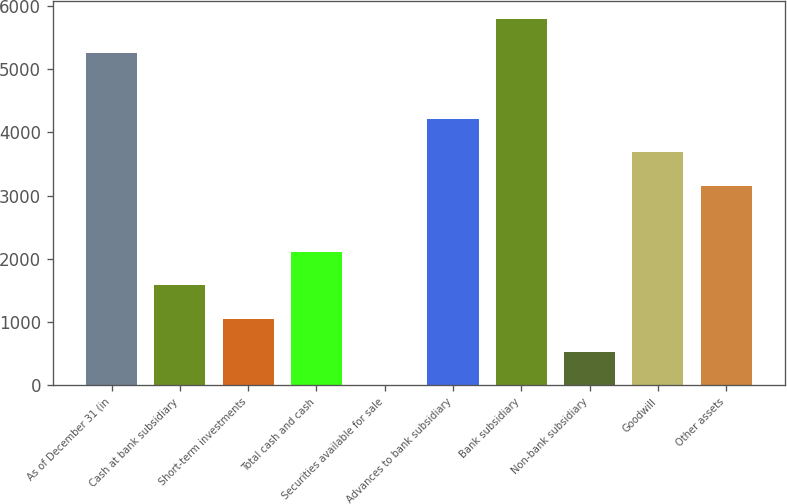Convert chart. <chart><loc_0><loc_0><loc_500><loc_500><bar_chart><fcel>As of December 31 (in<fcel>Cash at bank subsidiary<fcel>Short-term investments<fcel>Total cash and cash<fcel>Securities available for sale<fcel>Advances to bank subsidiary<fcel>Bank subsidiary<fcel>Non-bank subsidiary<fcel>Goodwill<fcel>Other assets<nl><fcel>5264.5<fcel>1579.49<fcel>1053.06<fcel>2105.92<fcel>0.2<fcel>4211.64<fcel>5790.93<fcel>526.63<fcel>3685.21<fcel>3158.78<nl></chart> 